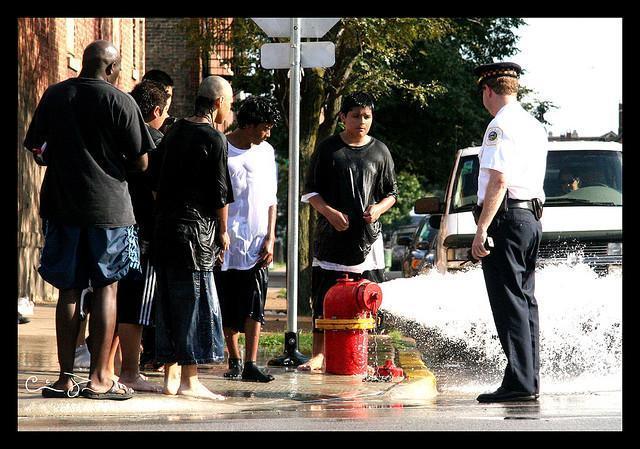How many people do you see?
Give a very brief answer. 7. How many people are there?
Give a very brief answer. 6. How many trucks are there?
Give a very brief answer. 1. How many zebras are looking around?
Give a very brief answer. 0. 